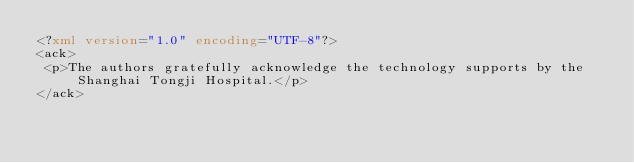<code> <loc_0><loc_0><loc_500><loc_500><_XML_><?xml version="1.0" encoding="UTF-8"?>
<ack>
 <p>The authors gratefully acknowledge the technology supports by the Shanghai Tongji Hospital.</p>
</ack>
</code> 